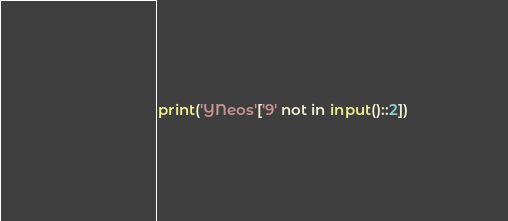<code> <loc_0><loc_0><loc_500><loc_500><_Python_>print('YNeos'['9' not in input()::2])</code> 